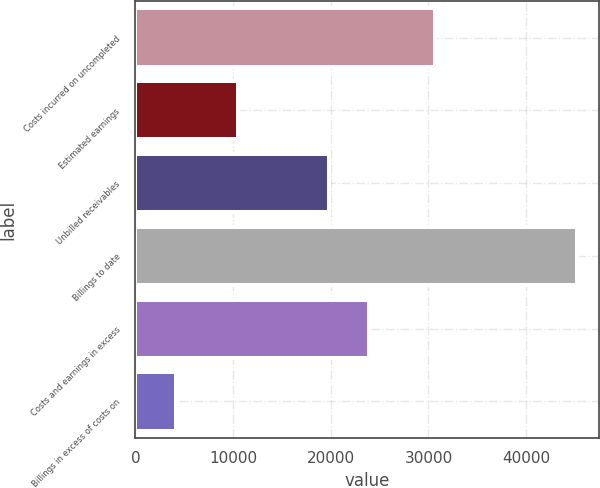Convert chart to OTSL. <chart><loc_0><loc_0><loc_500><loc_500><bar_chart><fcel>Costs incurred on uncompleted<fcel>Estimated earnings<fcel>Unbilled receivables<fcel>Billings to date<fcel>Costs and earnings in excess<fcel>Billings in excess of costs on<nl><fcel>30659<fcel>10519<fcel>19844<fcel>45168<fcel>23948.6<fcel>4122<nl></chart> 